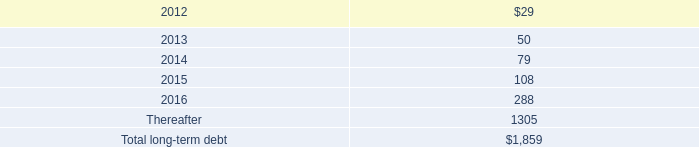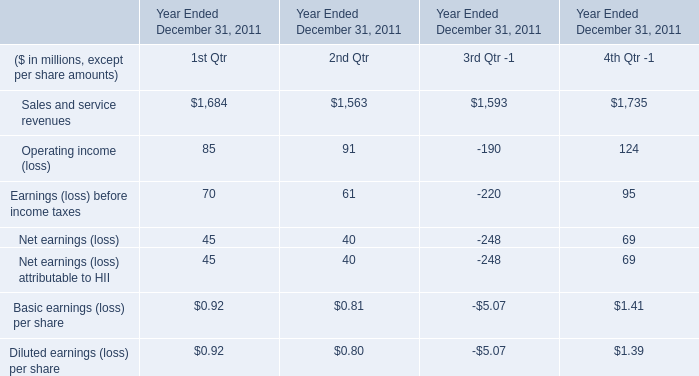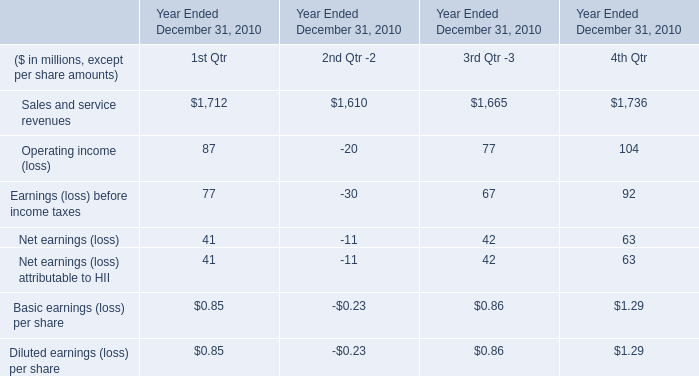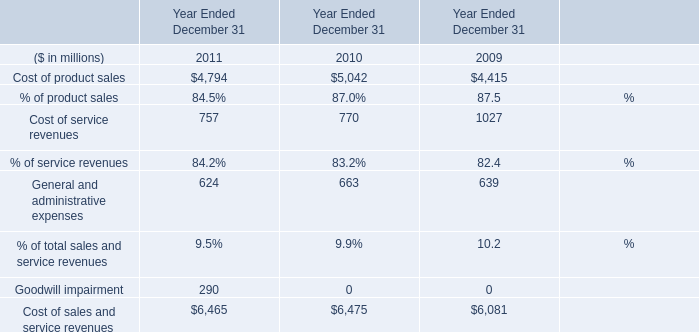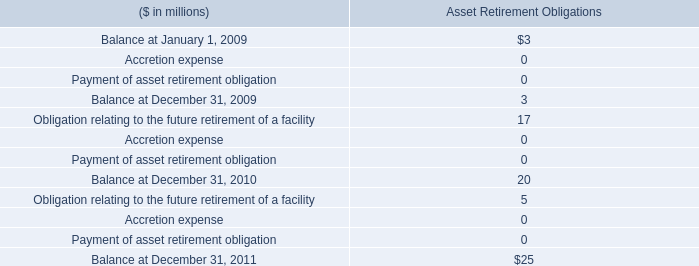What was the total amount of the General and administrative expenses in the years where Cost of service revenues greater than 0? (in million) 
Computations: ((624 + 663) + 639)
Answer: 1926.0. 